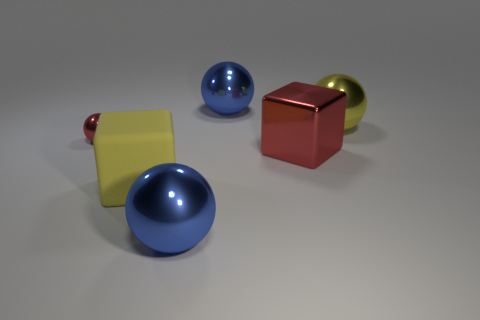Subtract all yellow balls. How many balls are left? 3 Subtract all small metal balls. How many balls are left? 3 Subtract all gray spheres. Subtract all purple cylinders. How many spheres are left? 4 Add 2 big matte blocks. How many objects exist? 8 Subtract all balls. How many objects are left? 2 Subtract all large blue metallic things. Subtract all large yellow spheres. How many objects are left? 3 Add 5 small things. How many small things are left? 6 Add 4 large cyan rubber blocks. How many large cyan rubber blocks exist? 4 Subtract 0 yellow cylinders. How many objects are left? 6 